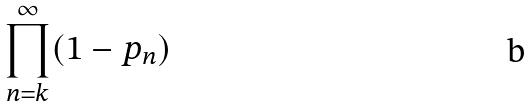<formula> <loc_0><loc_0><loc_500><loc_500>\prod _ { n = k } ^ { \infty } ( 1 - p _ { n } )</formula> 